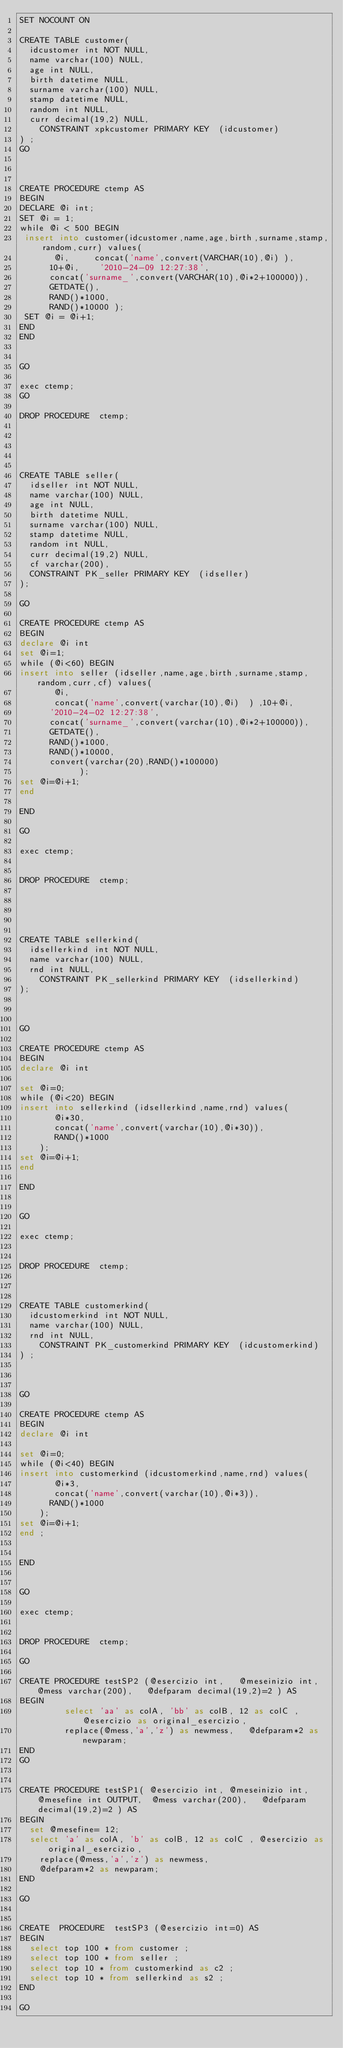Convert code to text. <code><loc_0><loc_0><loc_500><loc_500><_SQL_>SET NOCOUNT ON

CREATE TABLE customer(
	idcustomer int NOT NULL,
	name varchar(100) NULL,
	age int NULL,
	birth datetime NULL,
	surname varchar(100) NULL,
	stamp datetime NULL,
	random int NULL,
	curr decimal(19,2) NULL,
    CONSTRAINT xpkcustomer PRIMARY KEY  (idcustomer)
) ;
GO



CREATE PROCEDURE ctemp AS 
BEGIN
DECLARE @i int;
SET @i = 1;
while @i < 500 BEGIN
 insert into customer(idcustomer,name,age,birth,surname,stamp,random,curr) values(
			 @i, 		 concat('name',convert(VARCHAR(10),@i) ),
			10+@i,		'2010-24-09 12:27:38',
			concat('surname_',convert(VARCHAR(10),@i*2+100000)),
			GETDATE(),
			RAND()*1000,
			RAND()*10000 );
 SET @i = @i+1;
END 
END


GO

exec ctemp;
GO

DROP PROCEDURE  ctemp;





CREATE TABLE seller(
	idseller int NOT NULL,
	name varchar(100) NULL,
	age int NULL,
	birth datetime NULL,
	surname varchar(100) NULL,
	stamp datetime NULL,
	random int NULL,
	curr decimal(19,2) NULL,
	cf varchar(200),
	CONSTRAINT PK_seller PRIMARY KEY  (idseller)
);

GO

CREATE PROCEDURE ctemp AS
BEGIN
declare @i int
set @i=1;
while (@i<60) BEGIN
insert into seller (idseller,name,age,birth,surname,stamp,random,curr,cf) values(
			 @i,
			 concat('name',convert(varchar(10),@i)	)	,10+@i,
			'2010-24-02 12:27:38',
			concat('surname_',convert(varchar(10),@i*2+100000)),
			GETDATE(),
			RAND()*1000,
			RAND()*10000,
			convert(varchar(20),RAND()*100000)
            );
set @i=@i+1;
end 

END

GO

exec ctemp;


DROP PROCEDURE  ctemp;





CREATE TABLE sellerkind(
	idsellerkind int NOT NULL,
	name varchar(100) NULL,
	rnd int NULL,
    CONSTRAINT PK_sellerkind PRIMARY KEY  (idsellerkind)
);



GO

CREATE PROCEDURE ctemp AS 
BEGIN
declare @i int

set @i=0;
while (@i<20) BEGIN
insert into sellerkind (idsellerkind,name,rnd) values(
			 @i*30,
			 concat('name',convert(varchar(10),@i*30)),
			 RAND()*1000
		);
set @i=@i+1;
end 

END


GO

exec ctemp;


DROP PROCEDURE  ctemp;



CREATE TABLE customerkind(
	idcustomerkind int NOT NULL,
	name varchar(100) NULL,
	rnd int NULL,
    CONSTRAINT PK_customerkind PRIMARY KEY  (idcustomerkind)
) ;



GO

CREATE PROCEDURE ctemp AS
BEGIN
declare @i int

set @i=0;
while (@i<40) BEGIN
insert into customerkind (idcustomerkind,name,rnd) values(
			 @i*3,
			 concat('name',convert(varchar(10),@i*3)),
			RAND()*1000
		);
set @i=@i+1;
end ;


END


GO

exec ctemp;


DROP PROCEDURE  ctemp;

GO

CREATE PROCEDURE testSP2 (@esercizio int,   @meseinizio int,  @mess varchar(200),   @defparam decimal(19,2)=2 ) AS
BEGIN         
         select 'aa' as colA, 'bb' as colB, 12 as colC , @esercizio as original_esercizio,
         replace(@mess,'a','z') as newmess,   @defparam*2 as newparam;
END
GO


CREATE PROCEDURE testSP1( @esercizio int, @meseinizio int, @mesefine int OUTPUT,	@mess varchar(200), 	@defparam decimal(19,2)=2 ) AS
BEGIN
	set @mesefine= 12;
	select 'a' as colA, 'b' as colB, 12 as colC , @esercizio as original_esercizio,
		replace(@mess,'a','z') as newmess,
		@defparam*2 as newparam;
END

GO


CREATE  PROCEDURE  testSP3 (@esercizio int=0) AS
BEGIN
	select top 100 * from customer ;
	select top 100 * from seller ;
	select top 10 * from customerkind as c2 ;
	select top 10 * from sellerkind as s2 ;
END

GO
</code> 